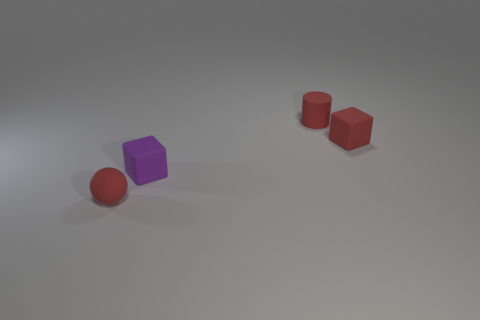What color is the small matte cylinder?
Ensure brevity in your answer.  Red. There is another thing that is the same shape as the purple matte object; what is it made of?
Provide a succinct answer. Rubber. Is there any other thing that has the same material as the red cylinder?
Give a very brief answer. Yes. Is the color of the sphere the same as the small matte cylinder?
Ensure brevity in your answer.  Yes. The small object on the left side of the small cube to the left of the small cylinder is what shape?
Provide a short and direct response. Sphere. There is a tiny purple object that is made of the same material as the small cylinder; what shape is it?
Provide a short and direct response. Cube. How many other objects are there of the same shape as the purple matte object?
Make the answer very short. 1. There is a matte cube that is behind the purple thing; does it have the same size as the purple rubber thing?
Give a very brief answer. Yes. Is the number of tiny spheres left of the small rubber ball greater than the number of things?
Make the answer very short. No. There is a tiny matte cube that is to the right of the rubber cylinder; what number of small red cylinders are in front of it?
Your answer should be very brief. 0. 